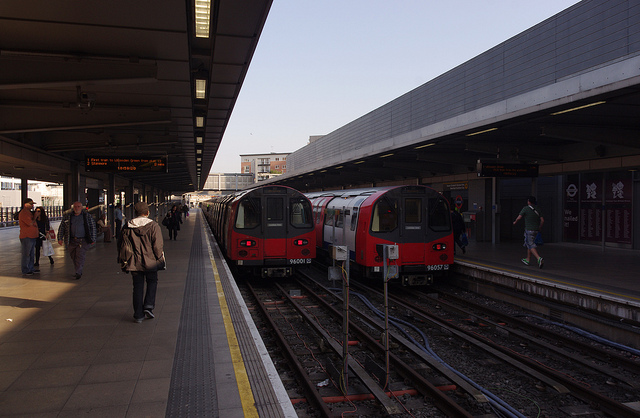<image>What stop number is listed on the sign? I don't know the stop number listed on the sign. It can be '6', '4' or '55'. What stop number is listed on the sign? It is uncertain what stop number is listed on the sign. It can be seen as '6', '4', '55', '3', '0', '17' or '4'. 